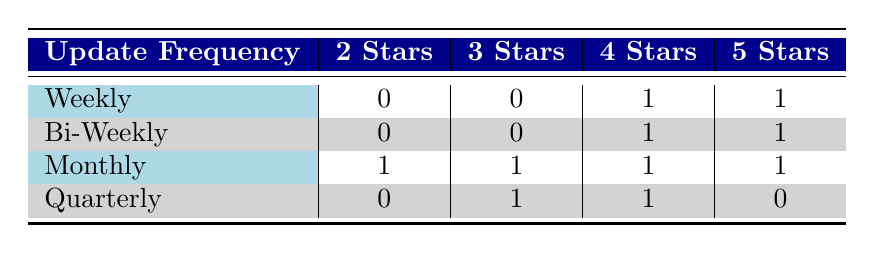What is the feedback rating for software updated quarterly? There is one piece of software that updates quarterly, which received a 3-star rating and a 4-star rating. Therefore, the feedback ratings for quarterly updates are 3 Stars and 4 Stars.
Answer: 3 Stars and 4 Stars How many software titles received a 2-star rating? From the table, we see that there was one software title that received a 2-star rating, which is listed under the monthly update frequency.
Answer: 1 What is the most common feedback rating for bi-weekly updated software? For bi-weekly frequency, there are two feedback ratings: one software received a 4-star rating and another received a 5-star rating. Since two distinct ratings occur, we cannot identify a "most common" rating.
Answer: There is no most common feedback rating Which update frequency has the highest number of 5-star ratings? From the table, we find that both weekly and bi-weekly update frequencies have one software each with a 5-star rating. However, the highest number of 5-star ratings occurs in the monthly frequency, where one software has a 5-star rating as well, so it is tied among them.
Answer: Tied (1 for weekly, bi-weekly, and monthly) Are there any software titles that received a different rating for the same update frequency? By reviewing the table, we can see that for the monthly frequency, there are different ratings: one software received a 2-star, another a 3-star, one a 4-star, and one a 5-star, thus confirming that several ratings exist for the same update frequency.
Answer: Yes 